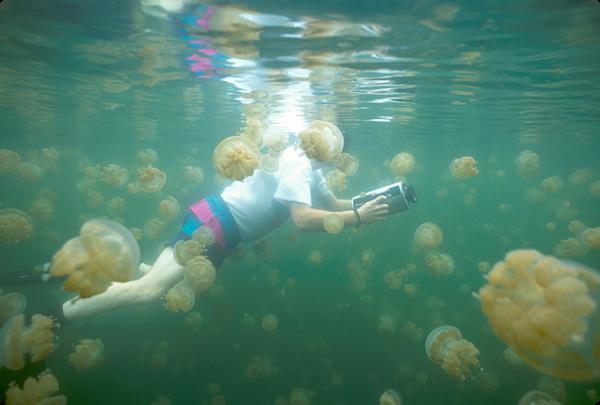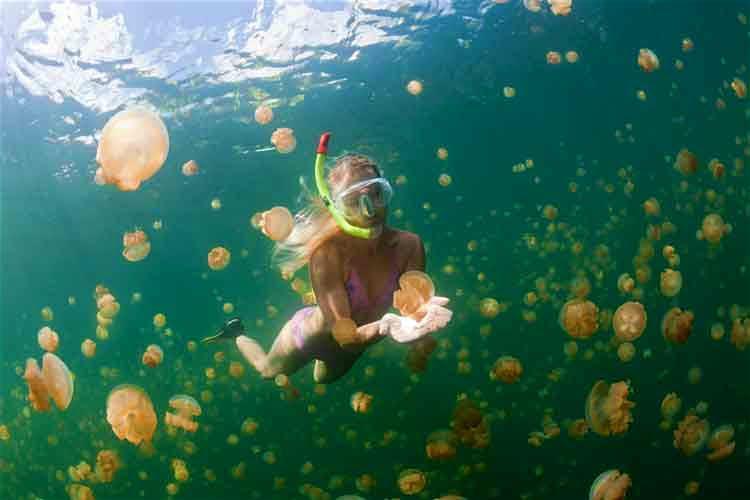The first image is the image on the left, the second image is the image on the right. For the images shown, is this caption "There are two divers with the jellyfish." true? Answer yes or no. Yes. The first image is the image on the left, the second image is the image on the right. Analyze the images presented: Is the assertion "At least one of the people swimming is at least partially silhouetted against the sky." valid? Answer yes or no. No. 